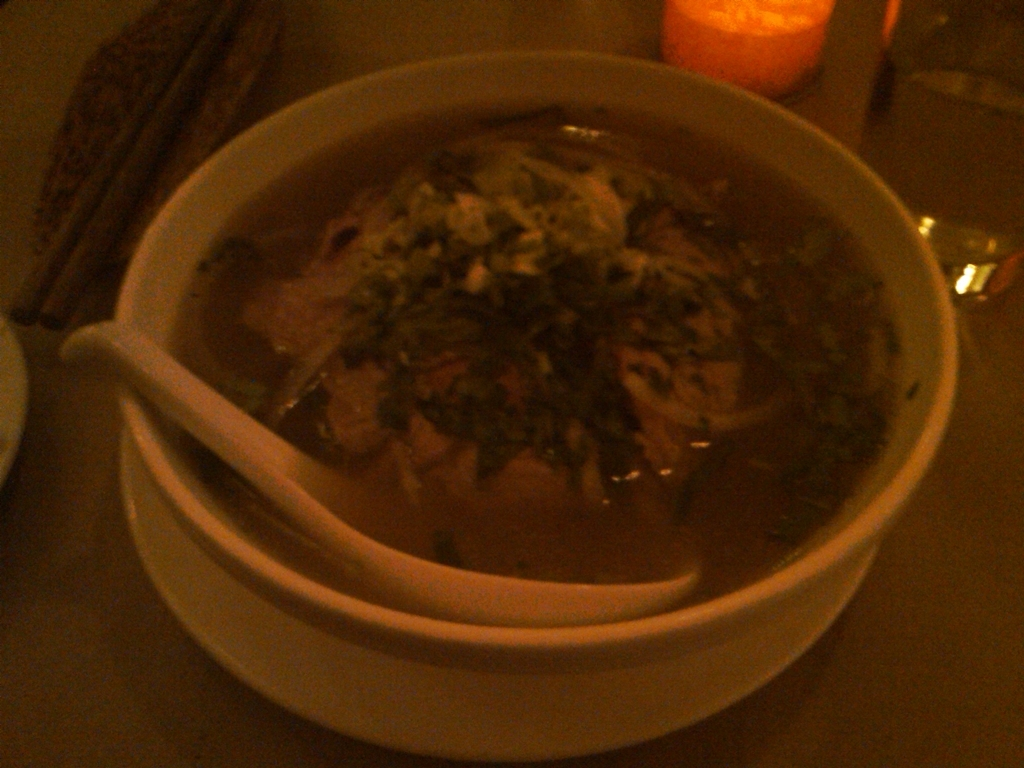What could be the possible cuisine or origin of this dish? Based on the visual cues, it could potentially be an East or Southeast Asian cuisine, as noodle soups with meat and fresh herbs are prominent in those food cultures. Specific identification would require a clearer image or more context. How could this dish be served or eaten? Such a dish is typically enjoyed hot, with chopsticks to handle the noodles and meat, complemented by a soup spoon for the broth. It's common to adjust the flavor with condiments like hot sauce, soy sauce, or lime, depending on personal preference and the specific type of soup. 